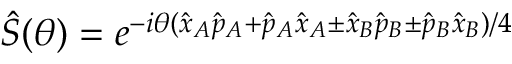Convert formula to latex. <formula><loc_0><loc_0><loc_500><loc_500>\hat { S } ( \theta ) = e ^ { - i \theta ( \hat { x } _ { A } \hat { p } _ { A } + \hat { p } _ { A } \hat { x } _ { A } \pm \hat { x } _ { B } \hat { p } _ { B } \pm \hat { p } _ { B } \hat { x } _ { B } ) / 4 }</formula> 